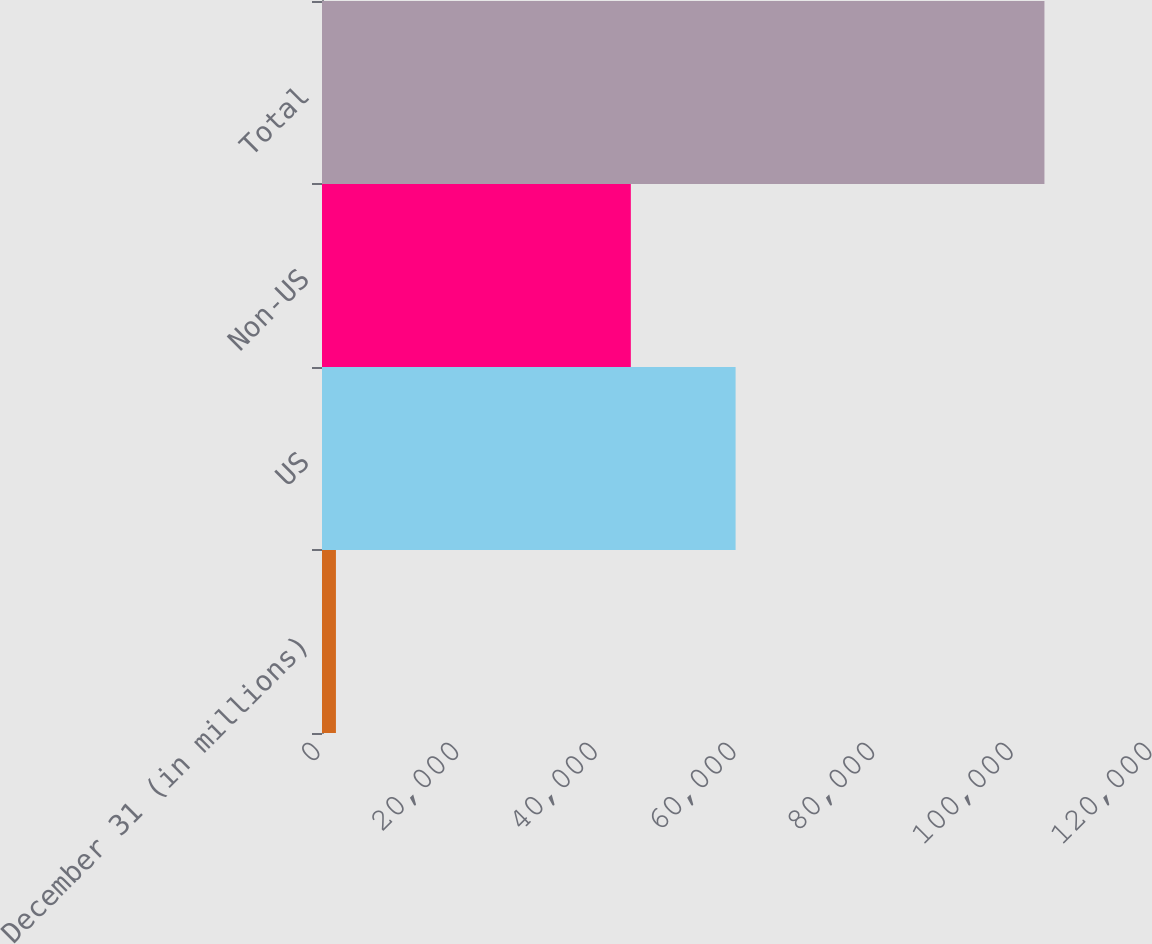Convert chart to OTSL. <chart><loc_0><loc_0><loc_500><loc_500><bar_chart><fcel>December 31 (in millions)<fcel>US<fcel>Non-US<fcel>Total<nl><fcel>2010<fcel>59653<fcel>44544<fcel>104197<nl></chart> 